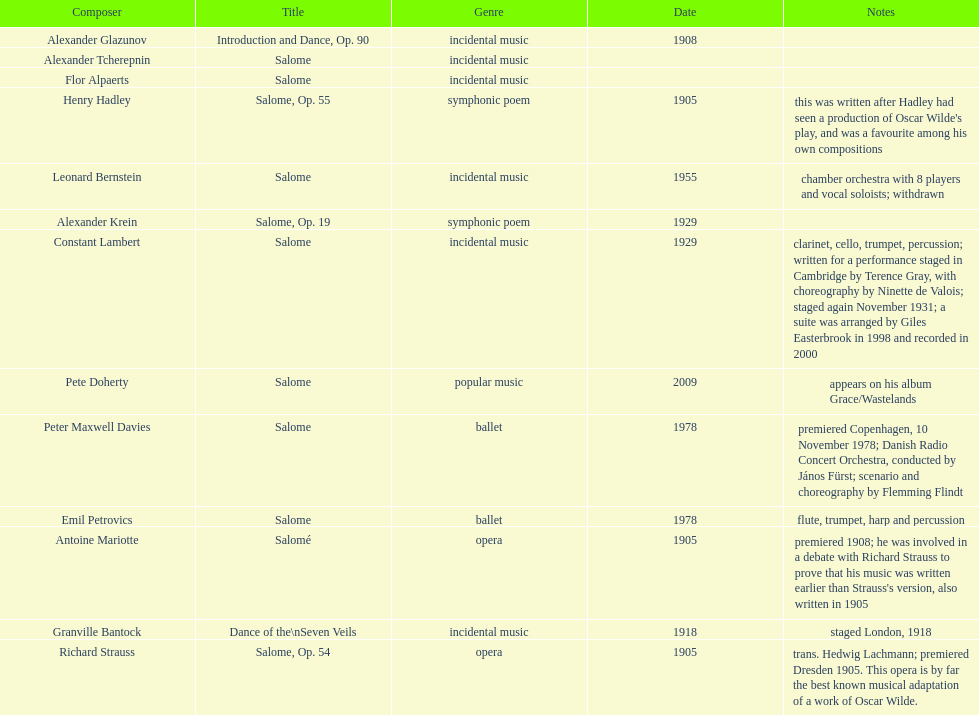Help me parse the entirety of this table. {'header': ['Composer', 'Title', 'Genre', 'Date', 'Notes'], 'rows': [['Alexander Glazunov', 'Introduction and Dance, Op. 90', 'incidental music', '1908', ''], ['Alexander\xa0Tcherepnin', 'Salome', 'incidental music', '', ''], ['Flor Alpaerts', 'Salome', 'incidental\xa0music', '', ''], ['Henry Hadley', 'Salome, Op. 55', 'symphonic poem', '1905', "this was written after Hadley had seen a production of Oscar Wilde's play, and was a favourite among his own compositions"], ['Leonard Bernstein', 'Salome', 'incidental music', '1955', 'chamber orchestra with 8 players and vocal soloists; withdrawn'], ['Alexander Krein', 'Salome, Op. 19', 'symphonic poem', '1929', ''], ['Constant Lambert', 'Salome', 'incidental music', '1929', 'clarinet, cello, trumpet, percussion; written for a performance staged in Cambridge by Terence Gray, with choreography by Ninette de Valois; staged again November 1931; a suite was arranged by Giles Easterbrook in 1998 and recorded in 2000'], ['Pete Doherty', 'Salome', 'popular music', '2009', 'appears on his album Grace/Wastelands'], ['Peter\xa0Maxwell\xa0Davies', 'Salome', 'ballet', '1978', 'premiered Copenhagen, 10 November 1978; Danish Radio Concert Orchestra, conducted by János Fürst; scenario and choreography by Flemming Flindt'], ['Emil Petrovics', 'Salome', 'ballet', '1978', 'flute, trumpet, harp and percussion'], ['Antoine Mariotte', 'Salomé', 'opera', '1905', "premiered 1908; he was involved in a debate with Richard Strauss to prove that his music was written earlier than Strauss's version, also written in 1905"], ['Granville Bantock', 'Dance of the\\nSeven Veils', 'incidental music', '1918', 'staged London, 1918'], ['Richard Strauss', 'Salome, Op. 54', 'opera', '1905', 'trans. Hedwig Lachmann; premiered Dresden 1905. This opera is by far the best known musical adaptation of a work of Oscar Wilde.']]} Who is next on the list after alexander krein? Constant Lambert. 